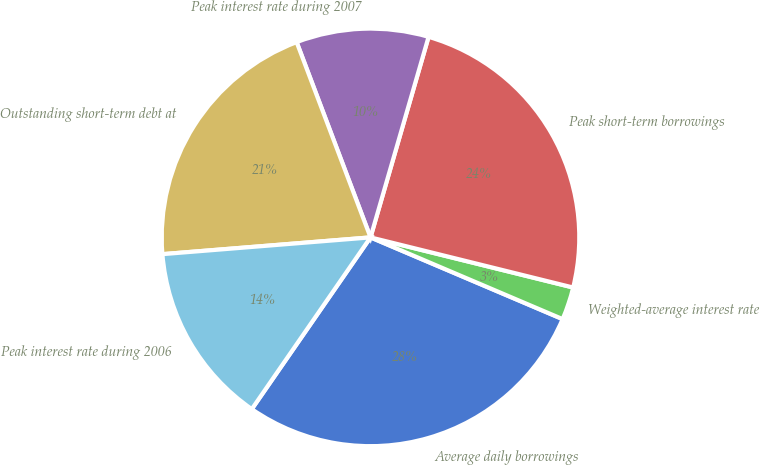<chart> <loc_0><loc_0><loc_500><loc_500><pie_chart><fcel>Average daily borrowings<fcel>Weighted-average interest rate<fcel>Peak short-term borrowings<fcel>Peak interest rate during 2007<fcel>Outstanding short-term debt at<fcel>Peak interest rate during 2006<nl><fcel>28.22%<fcel>2.54%<fcel>24.37%<fcel>10.24%<fcel>20.52%<fcel>14.09%<nl></chart> 